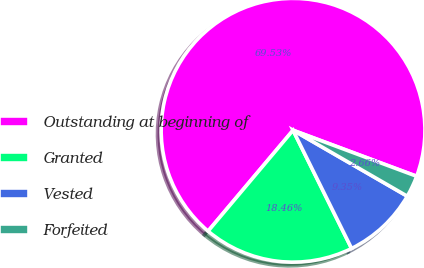Convert chart to OTSL. <chart><loc_0><loc_0><loc_500><loc_500><pie_chart><fcel>Outstanding at beginning of<fcel>Granted<fcel>Vested<fcel>Forfeited<nl><fcel>69.53%<fcel>18.46%<fcel>9.35%<fcel>2.66%<nl></chart> 